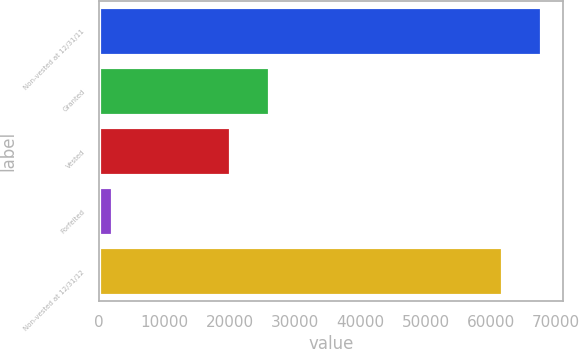Convert chart. <chart><loc_0><loc_0><loc_500><loc_500><bar_chart><fcel>Non-vested at 12/31/11<fcel>Granted<fcel>Vested<fcel>Forfeited<fcel>Non-vested at 12/31/12<nl><fcel>67691<fcel>25981<fcel>19980<fcel>1910<fcel>61690<nl></chart> 